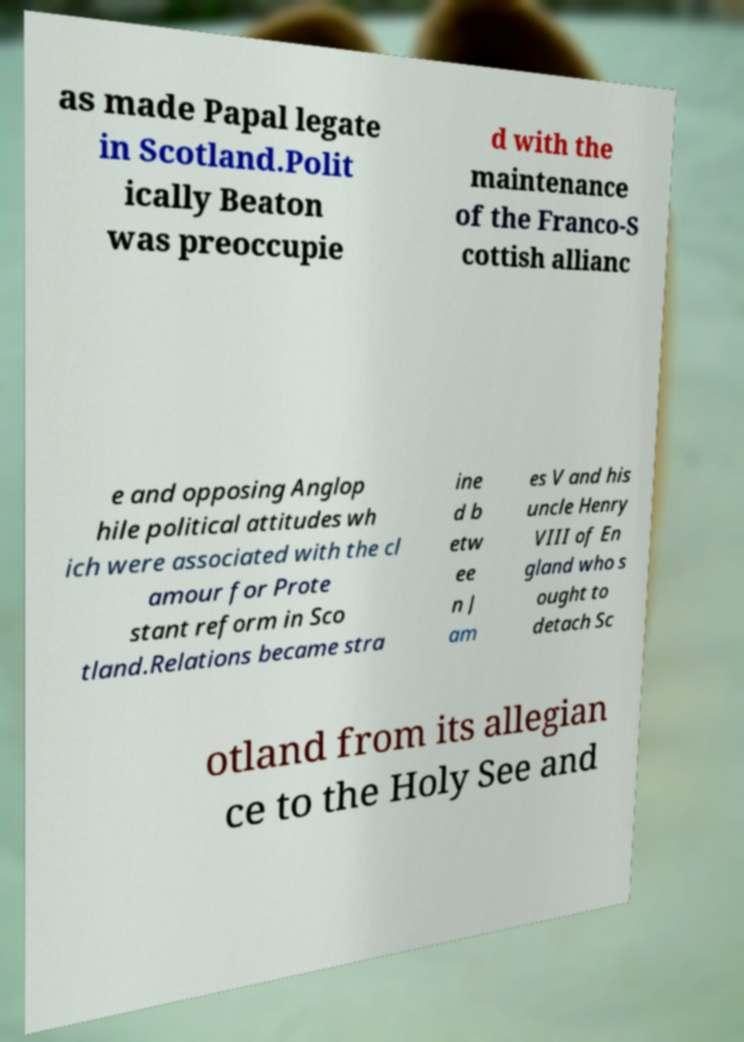Please identify and transcribe the text found in this image. as made Papal legate in Scotland.Polit ically Beaton was preoccupie d with the maintenance of the Franco-S cottish allianc e and opposing Anglop hile political attitudes wh ich were associated with the cl amour for Prote stant reform in Sco tland.Relations became stra ine d b etw ee n J am es V and his uncle Henry VIII of En gland who s ought to detach Sc otland from its allegian ce to the Holy See and 